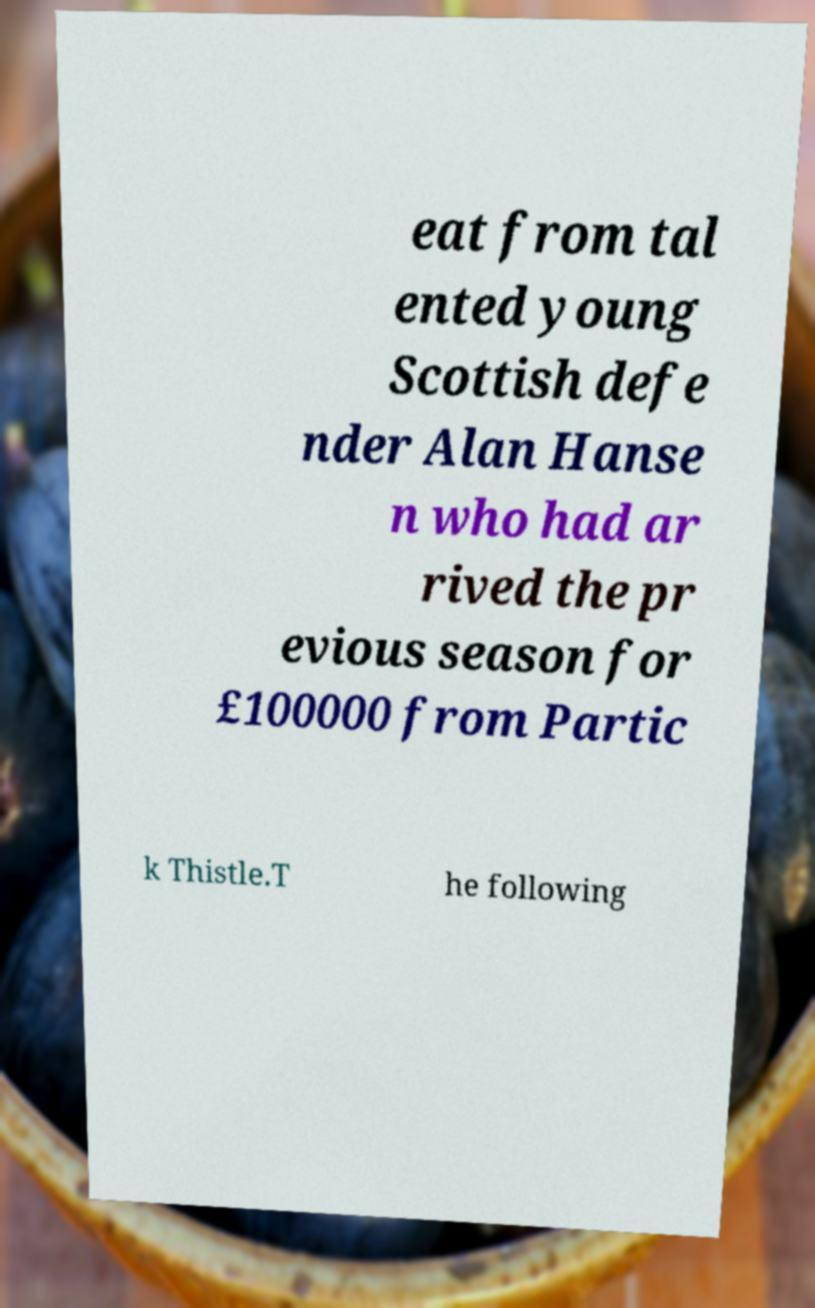There's text embedded in this image that I need extracted. Can you transcribe it verbatim? eat from tal ented young Scottish defe nder Alan Hanse n who had ar rived the pr evious season for £100000 from Partic k Thistle.T he following 